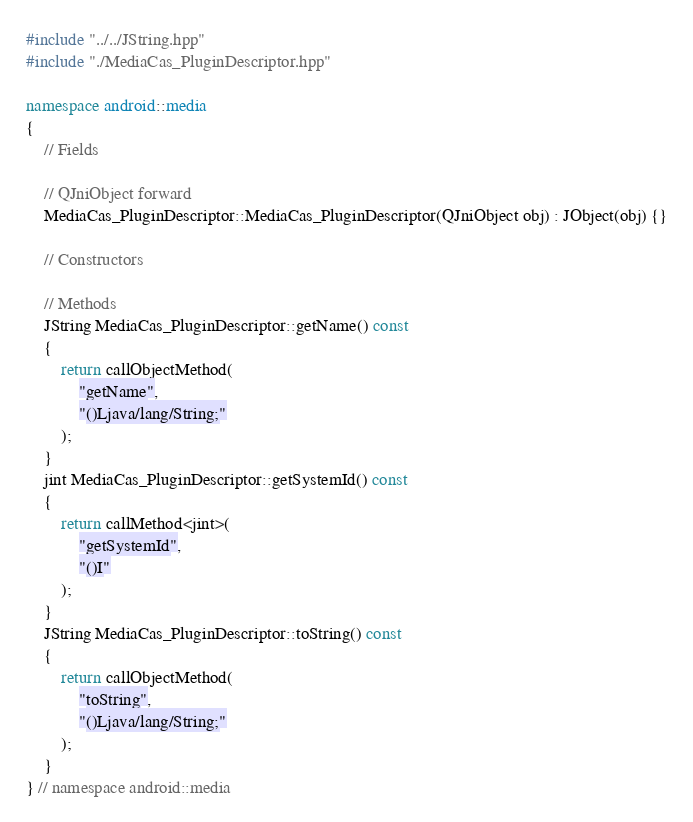Convert code to text. <code><loc_0><loc_0><loc_500><loc_500><_C++_>#include "../../JString.hpp"
#include "./MediaCas_PluginDescriptor.hpp"

namespace android::media
{
	// Fields
	
	// QJniObject forward
	MediaCas_PluginDescriptor::MediaCas_PluginDescriptor(QJniObject obj) : JObject(obj) {}
	
	// Constructors
	
	// Methods
	JString MediaCas_PluginDescriptor::getName() const
	{
		return callObjectMethod(
			"getName",
			"()Ljava/lang/String;"
		);
	}
	jint MediaCas_PluginDescriptor::getSystemId() const
	{
		return callMethod<jint>(
			"getSystemId",
			"()I"
		);
	}
	JString MediaCas_PluginDescriptor::toString() const
	{
		return callObjectMethod(
			"toString",
			"()Ljava/lang/String;"
		);
	}
} // namespace android::media

</code> 